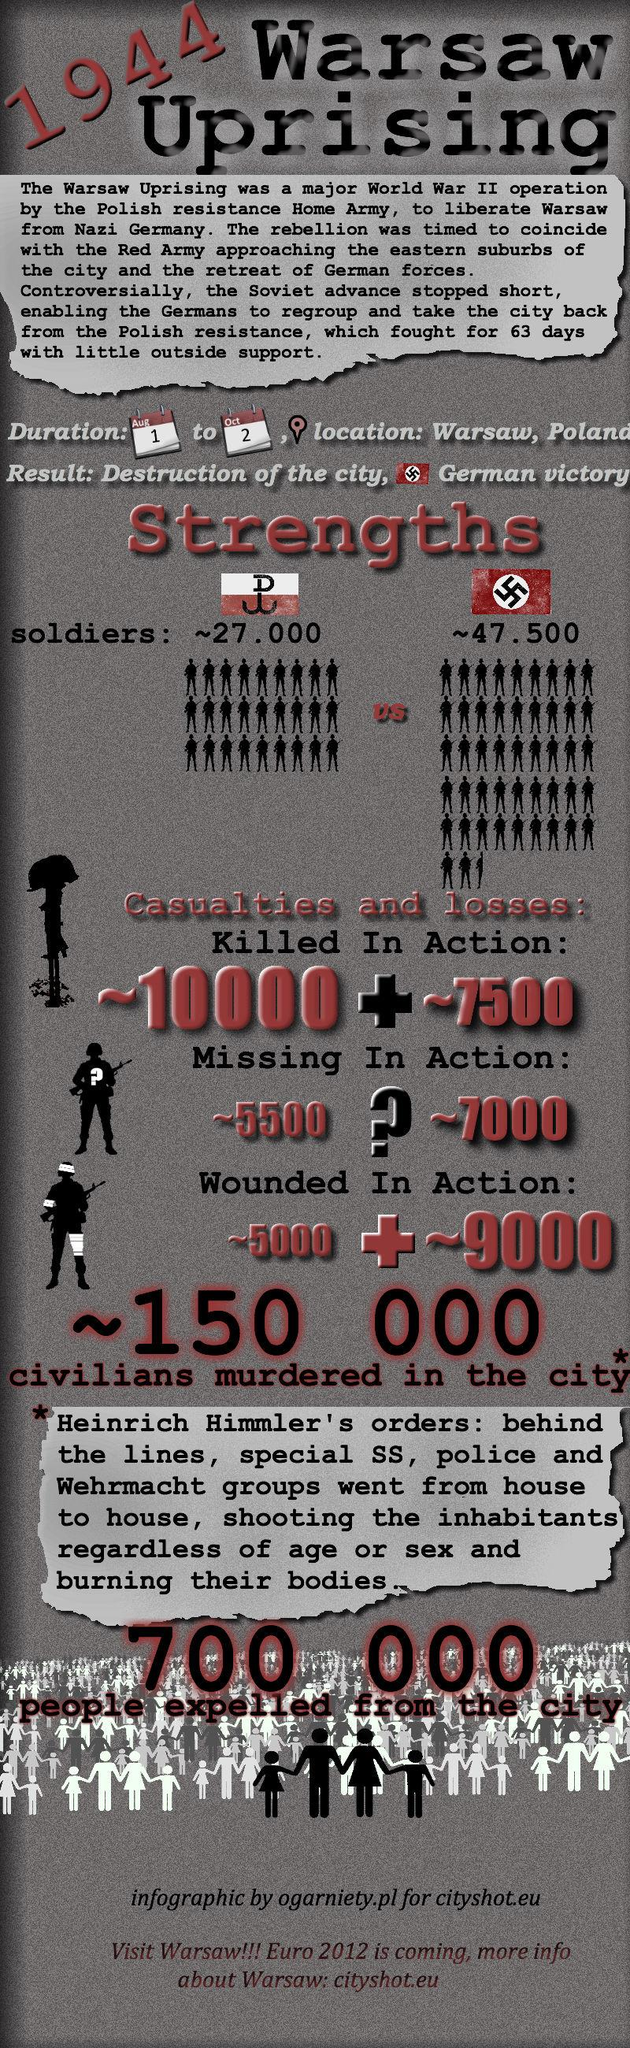Highlight a few significant elements in this photo. The Warsaw Uprising began on August 1, 1944. During the Warsaw Uprising in Germany, approximately 7,000 soldiers went missing. During the Warsaw Uprising, the strength of Poland was estimated to be around 27,000. During the Warsaw Uprising, approximately 7,500 soldiers of Germany were killed. During the Warsaw Uprising in Poland, approximately 10,000 soldiers were killed. 